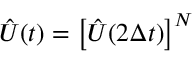Convert formula to latex. <formula><loc_0><loc_0><loc_500><loc_500>\hat { U } ( t ) = \left [ \hat { U } ( 2 \Delta t ) \right ] ^ { N }</formula> 